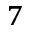Convert formula to latex. <formula><loc_0><loc_0><loc_500><loc_500>^ { 7 }</formula> 